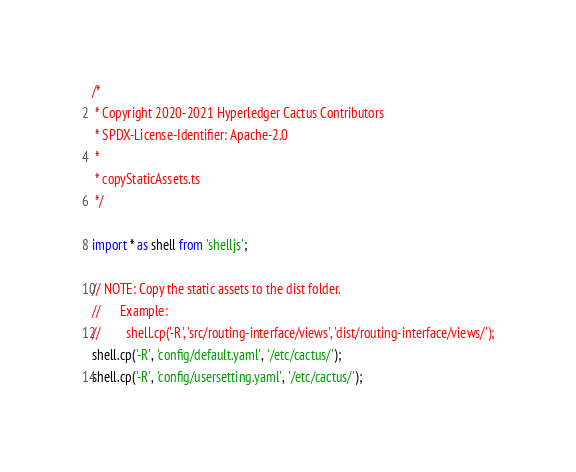Convert code to text. <code><loc_0><loc_0><loc_500><loc_500><_TypeScript_>/*
 * Copyright 2020-2021 Hyperledger Cactus Contributors
 * SPDX-License-Identifier: Apache-2.0
 *
 * copyStaticAssets.ts
 */

import * as shell from 'shelljs';

// NOTE: Copy the static assets to the dist folder.
//      Example:
//        shell.cp('-R', 'src/routing-interface/views', 'dist/routing-interface/views/');
shell.cp('-R', 'config/default.yaml', '/etc/cactus/');
shell.cp('-R', 'config/usersetting.yaml', '/etc/cactus/');
</code> 